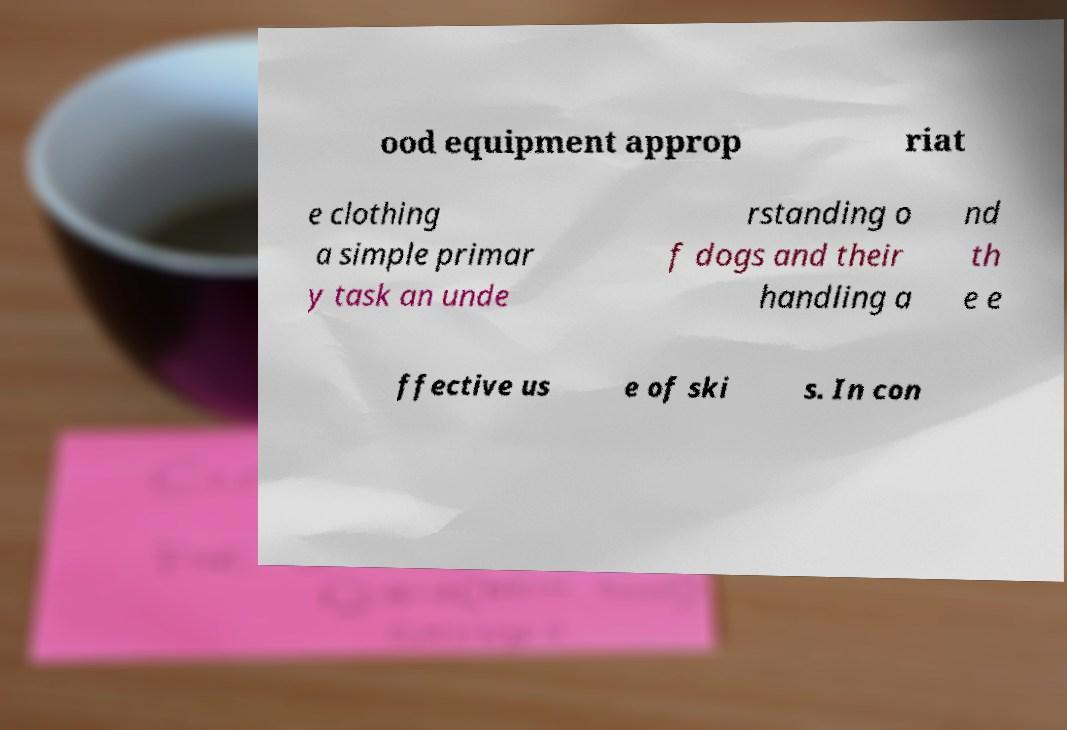Can you read and provide the text displayed in the image?This photo seems to have some interesting text. Can you extract and type it out for me? ood equipment approp riat e clothing a simple primar y task an unde rstanding o f dogs and their handling a nd th e e ffective us e of ski s. In con 